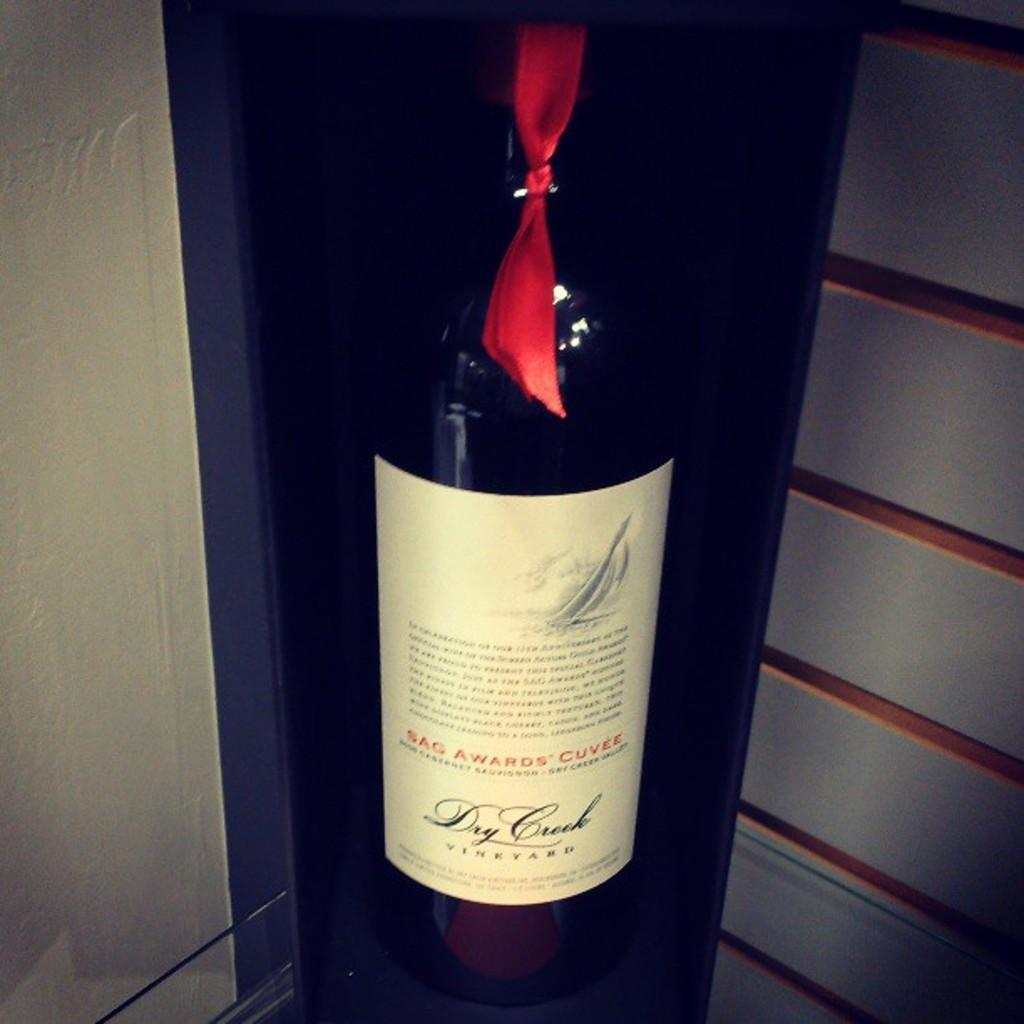<image>
Summarize the visual content of the image. a bottle of SAG AWARDS Cuvee with a red ribbon 